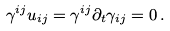Convert formula to latex. <formula><loc_0><loc_0><loc_500><loc_500>\gamma ^ { i j } u _ { i j } = \gamma ^ { i j } \partial _ { t } \gamma _ { i j } = 0 \, .</formula> 